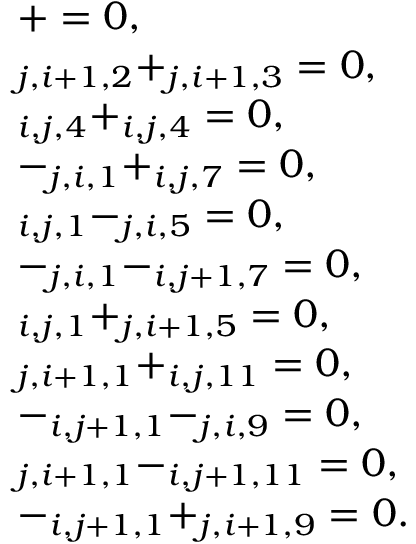Convert formula to latex. <formula><loc_0><loc_0><loc_500><loc_500>\begin{array} { r l } & { \quad + = 0 , } \\ & { \quad _ { j , i + 1 , 2 } + _ { j , i + 1 , 3 } = 0 , } \\ & { \quad _ { i , j , 4 } + _ { i , j , 4 } = 0 , } \\ & { \quad - _ { j , i , 1 } + _ { i , j , 7 } = 0 , } \\ & { \quad _ { i , j , 1 } - _ { j , i , 5 } = 0 , } \\ & { \quad - _ { j , i , 1 } - _ { i , j + 1 , 7 } = 0 , } \\ & { \quad _ { i , j , 1 } + _ { j , i + 1 , 5 } = 0 , } \\ & { \quad _ { j , i + 1 , 1 } + _ { i , j , 1 1 } = 0 , } \\ & { \quad - _ { i , j + 1 , 1 } - _ { j , i , 9 } = 0 , } \\ & { \quad _ { j , i + 1 , 1 } - _ { i , j + 1 , 1 1 } = 0 , } \\ & { \quad - _ { i , j + 1 , 1 } + _ { j , i + 1 , 9 } = 0 . } \end{array}</formula> 